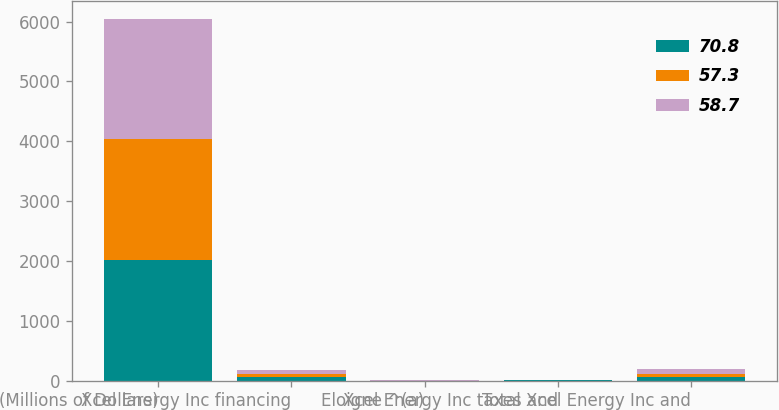Convert chart to OTSL. <chart><loc_0><loc_0><loc_500><loc_500><stacked_bar_chart><ecel><fcel>(Millions of Dollars)<fcel>Xcel Energy Inc financing<fcel>Eloigne ^(a)<fcel>Xcel Energy Inc taxes and<fcel>Total Xcel Energy Inc and<nl><fcel>70.8<fcel>2015<fcel>56.1<fcel>0.1<fcel>2.7<fcel>58.7<nl><fcel>57.3<fcel>2014<fcel>51.8<fcel>0.5<fcel>5<fcel>57.3<nl><fcel>58.7<fcel>2013<fcel>62.9<fcel>0.8<fcel>7.1<fcel>70.8<nl></chart> 